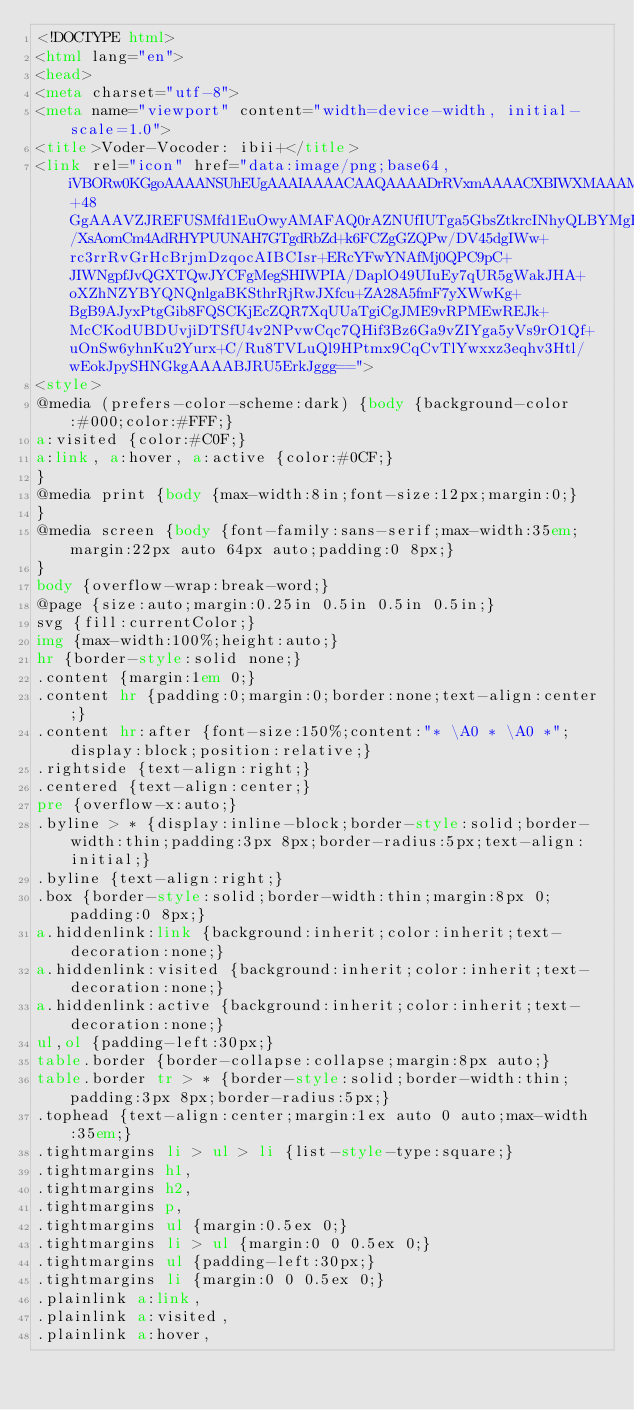<code> <loc_0><loc_0><loc_500><loc_500><_HTML_><!DOCTYPE html>
<html lang="en">
<head>
<meta charset="utf-8">
<meta name="viewport" content="width=device-width, initial-scale=1.0">
<title>Voder-Vocoder: ibii+</title>
<link rel="icon" href="data:image/png;base64,iVBORw0KGgoAAAANSUhEUgAAAIAAAACAAQAAAADrRVxmAAAACXBIWXMAAAMfAAADHwHmEQywAAAAGXRFWHRTb2Z0d2FyZQB3d3cuaW5rc2NhcGUub3Jnm+48GgAAAVZJREFUSMfd1EuOwyAMAFAQ0rAZNUfIUTga5GbsZtkrcINhyQLBYMgHG6ZddJcoSpOXDzY2ZZls7F5Q9iAzhyu/XsAomCm4AdRHYPUUNAH7GTgdRbZd+k6FCZgGZQPw/DV45dgIWw+rc3rrRvGrHcBrjmDzqocAIBCIsr+ERcYFwYNAfMj0QPC9pC+JIWNgpfJvQGXTQwJYCFgMegSHIWPIA/DaplO49UIuEy7qUR5gWakJHA+oXZhNZYBYQNQnlgaBKSthrRjRwJXfcu+ZA28A5fmF7yXWwKg+BgB9AJyxPtgGib8FQSCKjEcZQR7XqUUaTgiCgJME9vRPMEwREJk+McCKodUBDUvjiDTSfU4v2NPvwCqc7QHif3Bz6Ga9vZIYga5yVs9rO1Qf+uOnSw6yhnKu2Yurx+C/Ru8TVLuQl9HPtmx9CqCvTlYwxxz3eqhv3Htl/wEokJpySHNGkgAAAABJRU5ErkJggg==">
<style>
@media (prefers-color-scheme:dark) {body {background-color:#000;color:#FFF;}
a:visited {color:#C0F;}
a:link, a:hover, a:active {color:#0CF;}
}
@media print {body {max-width:8in;font-size:12px;margin:0;}
}
@media screen {body {font-family:sans-serif;max-width:35em;margin:22px auto 64px auto;padding:0 8px;}
}
body {overflow-wrap:break-word;}
@page {size:auto;margin:0.25in 0.5in 0.5in 0.5in;}
svg {fill:currentColor;}
img {max-width:100%;height:auto;}
hr {border-style:solid none;}
.content {margin:1em 0;}
.content hr {padding:0;margin:0;border:none;text-align:center;}
.content hr:after {font-size:150%;content:"* \A0 * \A0 *";display:block;position:relative;}
.rightside {text-align:right;}
.centered {text-align:center;}
pre {overflow-x:auto;}
.byline > * {display:inline-block;border-style:solid;border-width:thin;padding:3px 8px;border-radius:5px;text-align:initial;}
.byline {text-align:right;}
.box {border-style:solid;border-width:thin;margin:8px 0;padding:0 8px;}
a.hiddenlink:link {background:inherit;color:inherit;text-decoration:none;}
a.hiddenlink:visited {background:inherit;color:inherit;text-decoration:none;}
a.hiddenlink:active {background:inherit;color:inherit;text-decoration:none;}
ul,ol {padding-left:30px;}
table.border {border-collapse:collapse;margin:8px auto;}
table.border tr > * {border-style:solid;border-width:thin;padding:3px 8px;border-radius:5px;}
.tophead {text-align:center;margin:1ex auto 0 auto;max-width:35em;}
.tightmargins li > ul > li {list-style-type:square;}
.tightmargins h1,
.tightmargins h2,
.tightmargins p,
.tightmargins ul {margin:0.5ex 0;}
.tightmargins li > ul {margin:0 0 0.5ex 0;}
.tightmargins ul {padding-left:30px;}
.tightmargins li {margin:0 0 0.5ex 0;}
.plainlink a:link,
.plainlink a:visited,
.plainlink a:hover,</code> 